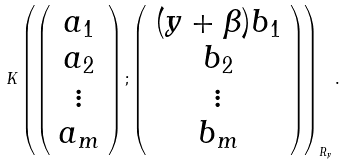Convert formula to latex. <formula><loc_0><loc_0><loc_500><loc_500>K \left ( \left ( \begin{array} { c } a _ { 1 } \\ a _ { 2 } \\ \vdots \\ a _ { m } \end{array} \right ) ; \left ( \begin{array} { c } ( y + \beta ) b _ { 1 } \\ b _ { 2 } \\ \vdots \\ b _ { m } \end{array} \right ) \right ) _ { R _ { y } } .</formula> 